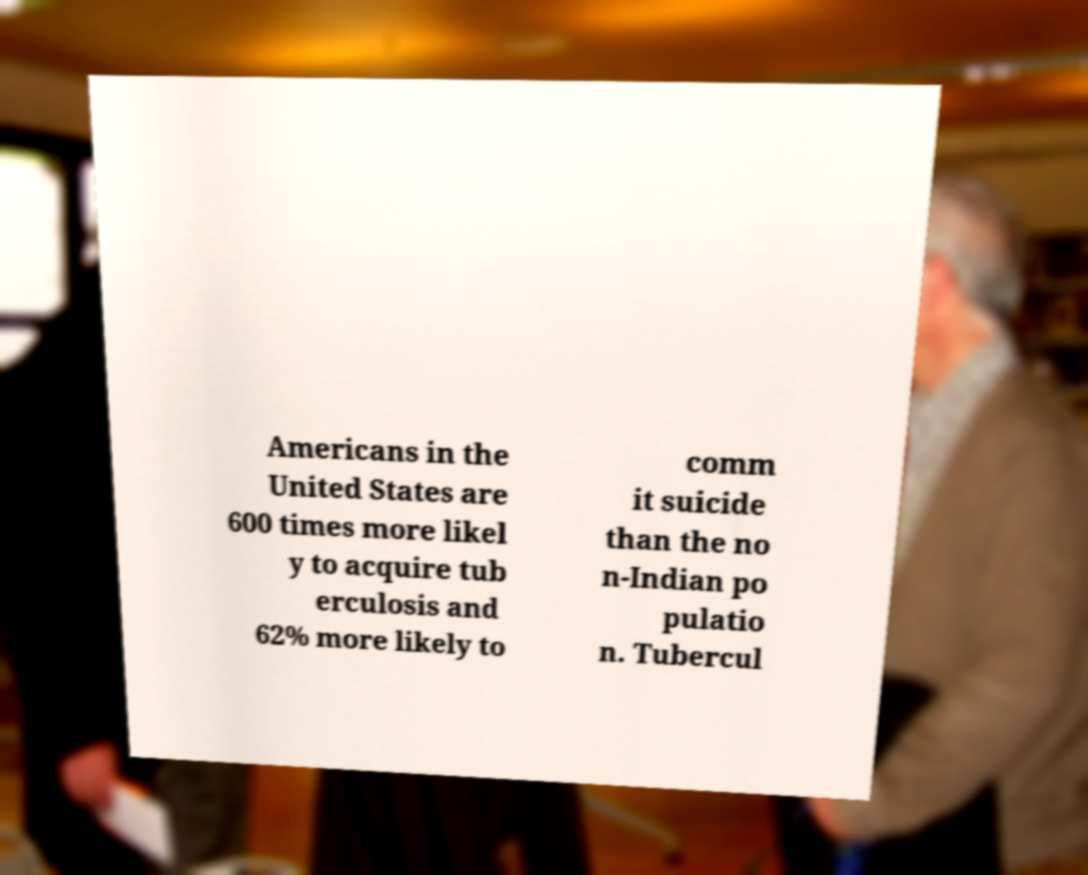I need the written content from this picture converted into text. Can you do that? Americans in the United States are 600 times more likel y to acquire tub erculosis and 62% more likely to comm it suicide than the no n-Indian po pulatio n. Tubercul 